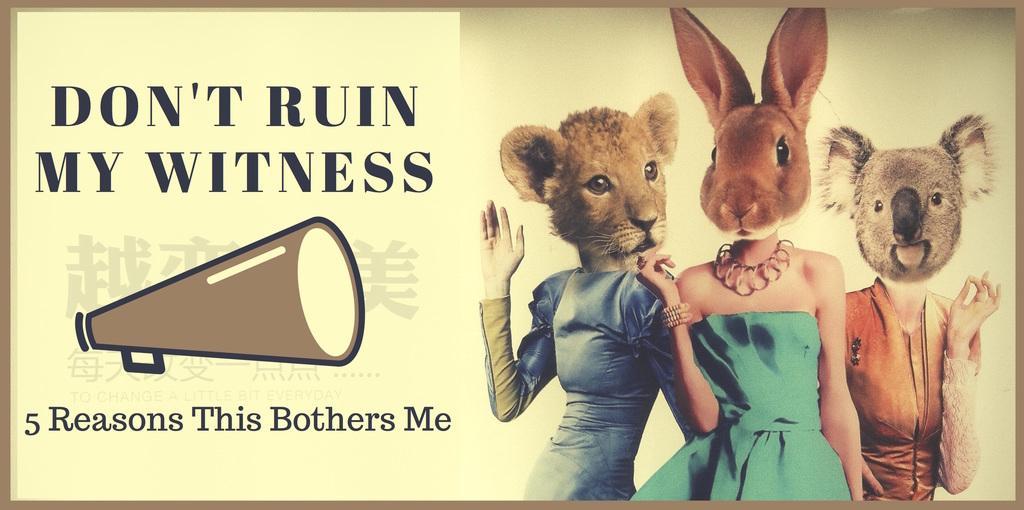How would you summarize this image in a sentence or two? In this picture we can see a poster, in the poster we can find some text and few people with animal faces. 